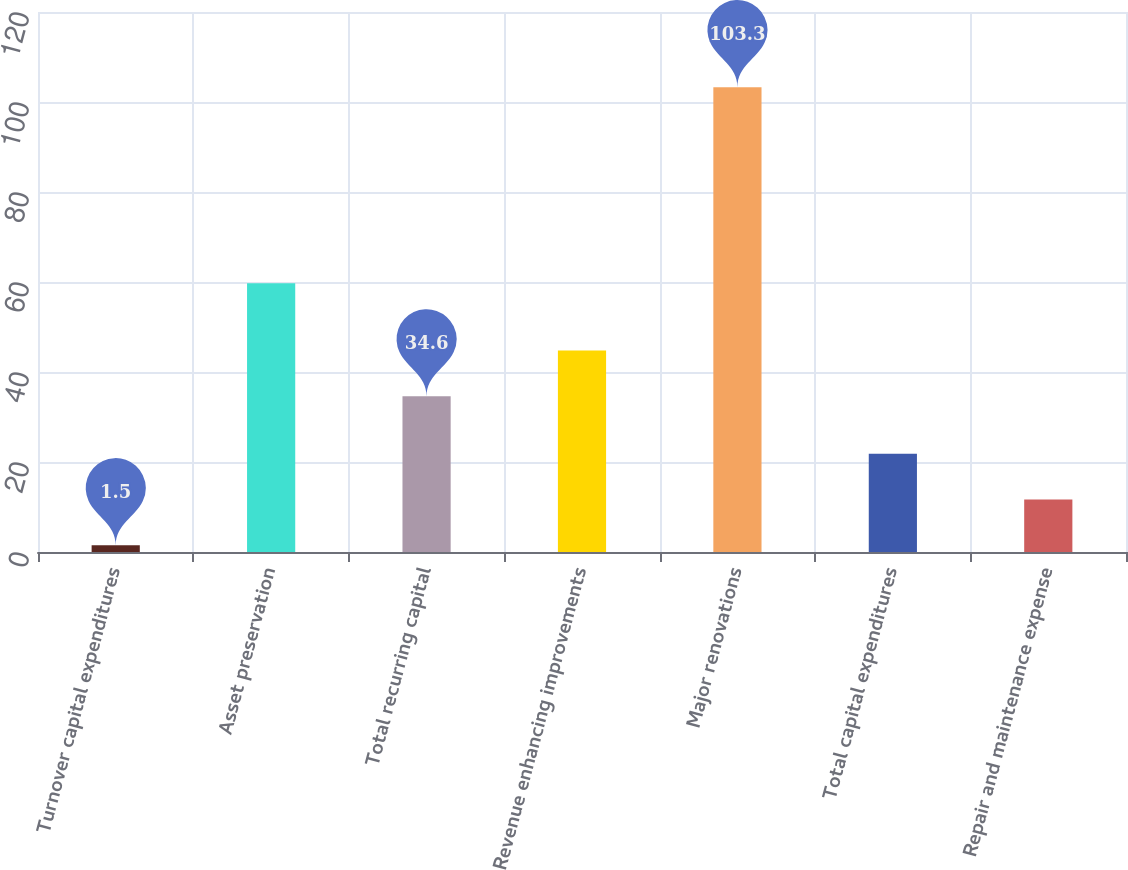Convert chart to OTSL. <chart><loc_0><loc_0><loc_500><loc_500><bar_chart><fcel>Turnover capital expenditures<fcel>Asset preservation<fcel>Total recurring capital<fcel>Revenue enhancing improvements<fcel>Major renovations<fcel>Total capital expenditures<fcel>Repair and maintenance expense<nl><fcel>1.5<fcel>59.7<fcel>34.6<fcel>44.78<fcel>103.3<fcel>21.86<fcel>11.68<nl></chart> 